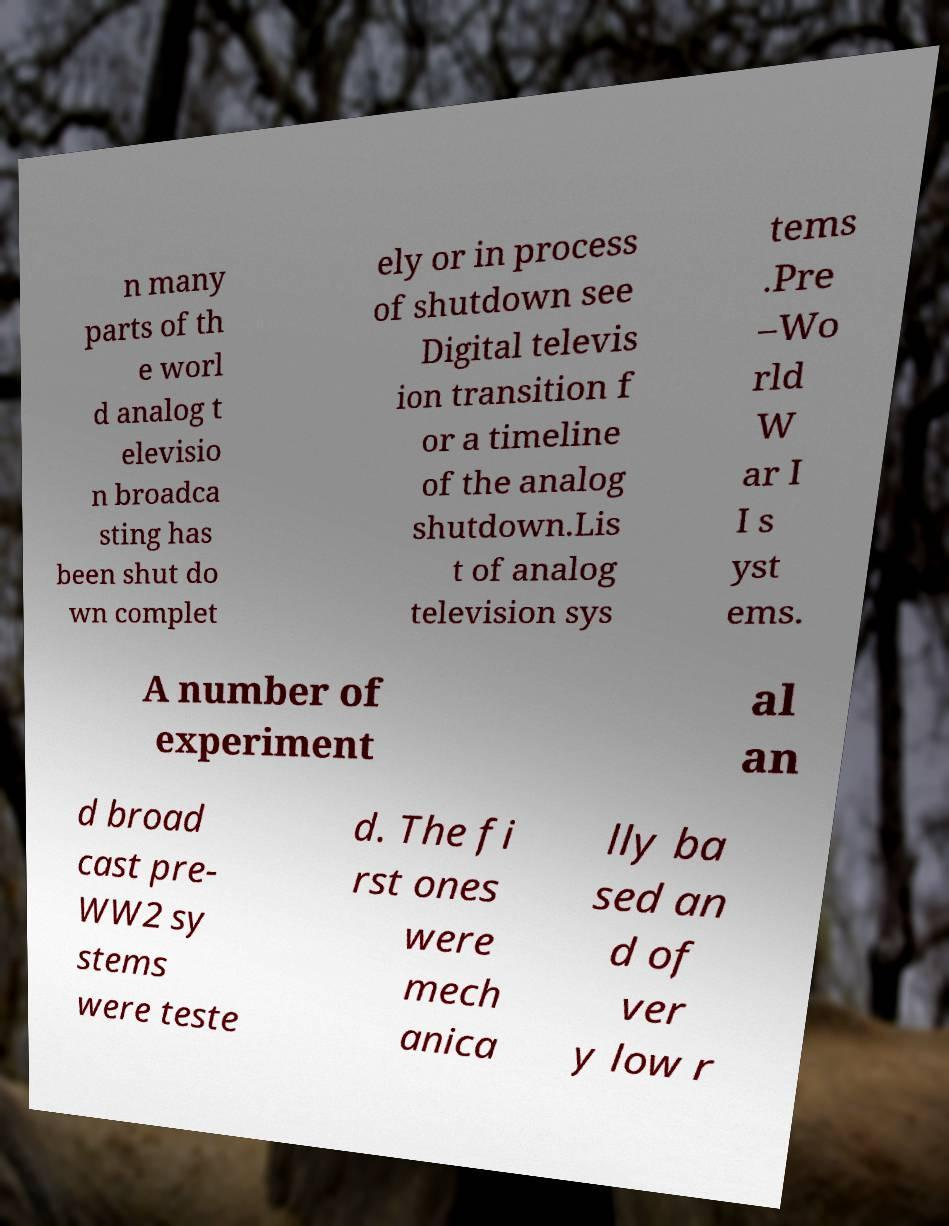Please read and relay the text visible in this image. What does it say? n many parts of th e worl d analog t elevisio n broadca sting has been shut do wn complet ely or in process of shutdown see Digital televis ion transition f or a timeline of the analog shutdown.Lis t of analog television sys tems .Pre –Wo rld W ar I I s yst ems. A number of experiment al an d broad cast pre- WW2 sy stems were teste d. The fi rst ones were mech anica lly ba sed an d of ver y low r 